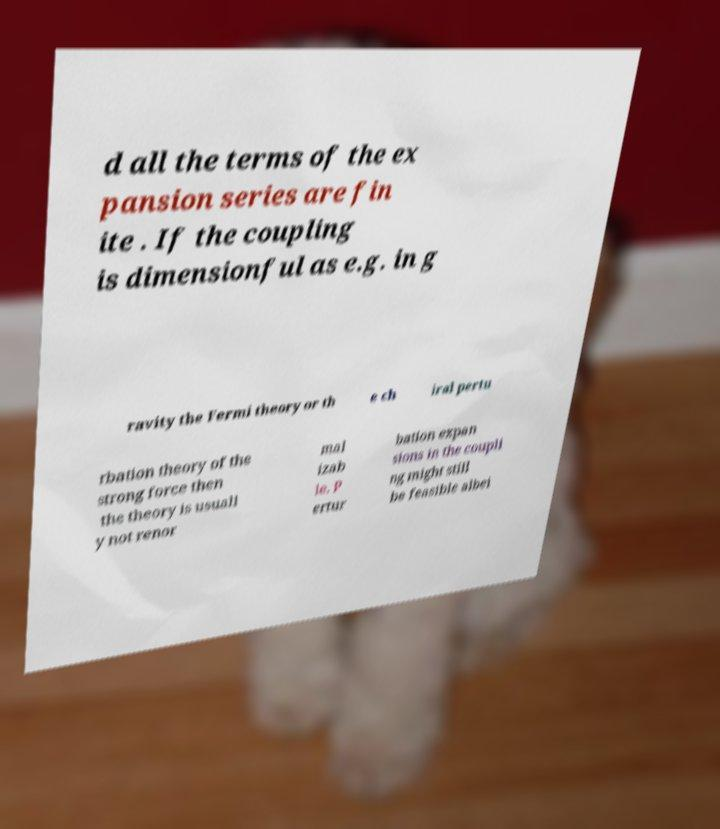What messages or text are displayed in this image? I need them in a readable, typed format. d all the terms of the ex pansion series are fin ite . If the coupling is dimensionful as e.g. in g ravity the Fermi theory or th e ch iral pertu rbation theory of the strong force then the theory is usuall y not renor mal izab le. P ertur bation expan sions in the coupli ng might still be feasible albei 